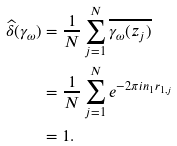<formula> <loc_0><loc_0><loc_500><loc_500>\widehat { \delta } ( \gamma _ { \omega } ) & = \frac { 1 } { N } \sum _ { j = 1 } ^ { N } \overline { \gamma _ { \omega } ( z _ { j } ) } \\ & = \frac { 1 } { N } \sum _ { j = 1 } ^ { N } e ^ { - 2 \pi i n _ { 1 } r _ { 1 , j } } \\ & = 1 .</formula> 